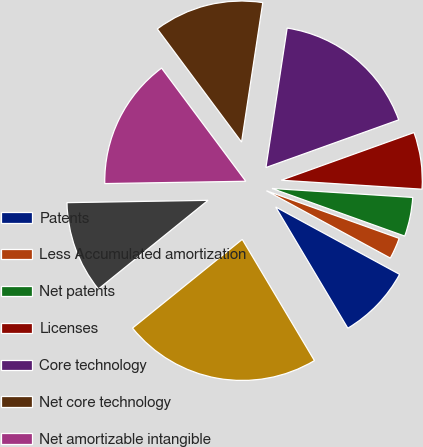Convert chart to OTSL. <chart><loc_0><loc_0><loc_500><loc_500><pie_chart><fcel>Patents<fcel>Less Accumulated amortization<fcel>Net patents<fcel>Licenses<fcel>Core technology<fcel>Net core technology<fcel>Net amortizable intangible<fcel>Trade names and trademarks<fcel>Totals<nl><fcel>8.53%<fcel>2.44%<fcel>4.47%<fcel>6.5%<fcel>17.11%<fcel>12.59%<fcel>15.08%<fcel>10.56%<fcel>22.73%<nl></chart> 